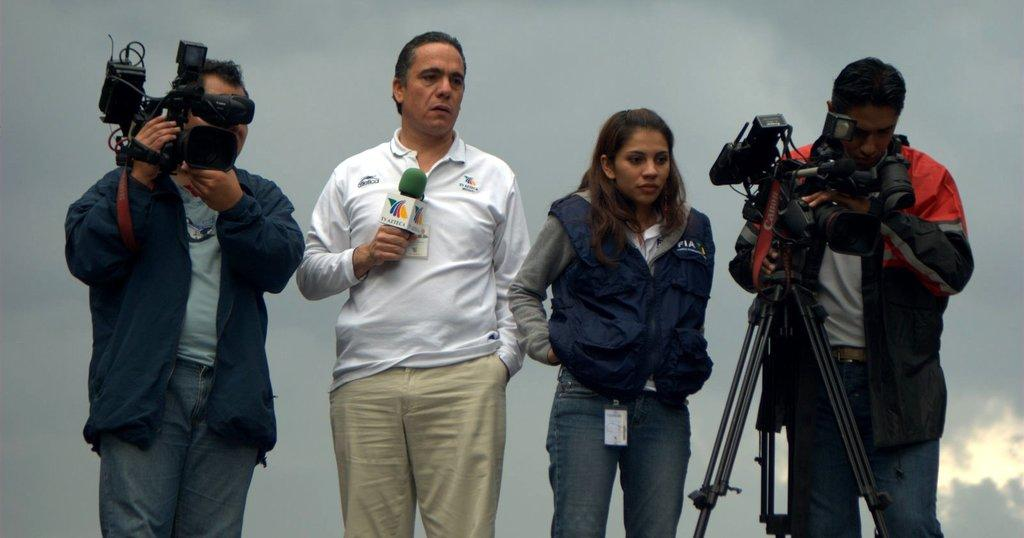How many people are in the image? There are three men and a woman in the image, making a total of four people. What are the individuals in the image doing? The individuals are standing in the image. What are the people wearing? They are wearing clothes. What equipment can be seen in the image? There are two video cameras and a microphone in the image. What is the weather like in the image? The sky appears to be cloudy, suggesting a potentially overcast or rainy day. Where is the sofa located in the image? There is no sofa present in the image. What type of machine is being operated by the individuals in the image? There is no machine being operated by the individuals in the image; they are simply standing with video cameras and a microphone. 